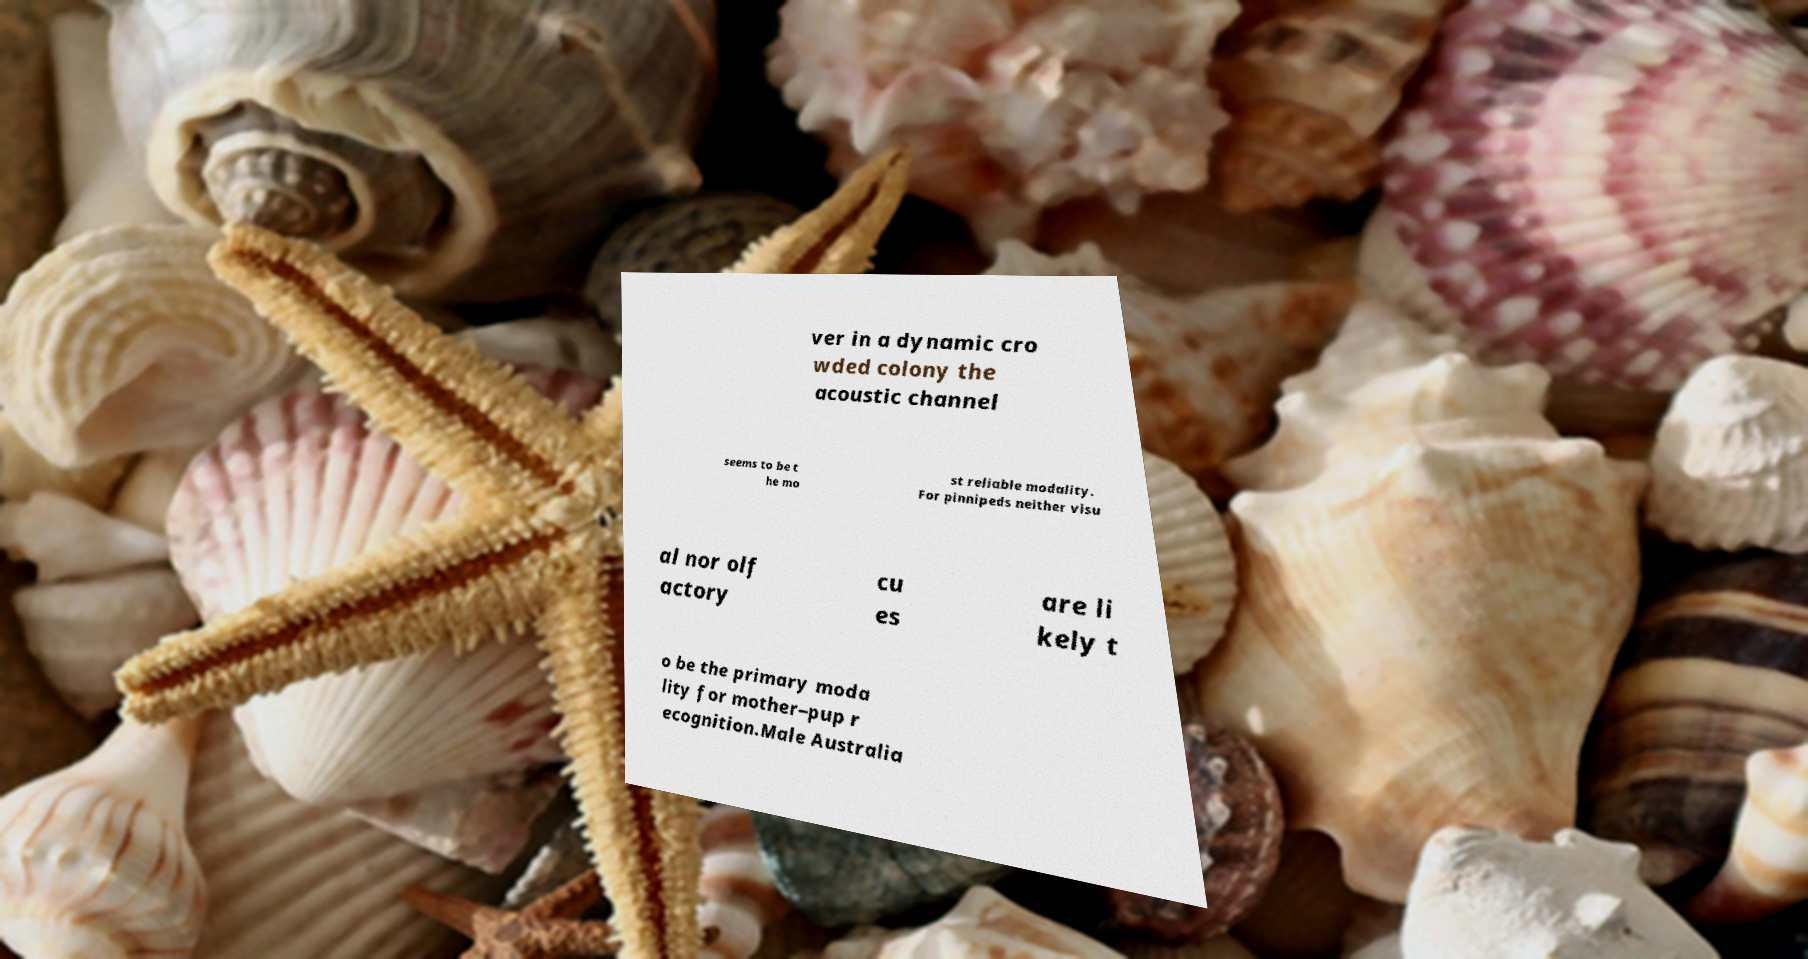Can you read and provide the text displayed in the image?This photo seems to have some interesting text. Can you extract and type it out for me? ver in a dynamic cro wded colony the acoustic channel seems to be t he mo st reliable modality. For pinnipeds neither visu al nor olf actory cu es are li kely t o be the primary moda lity for mother–pup r ecognition.Male Australia 